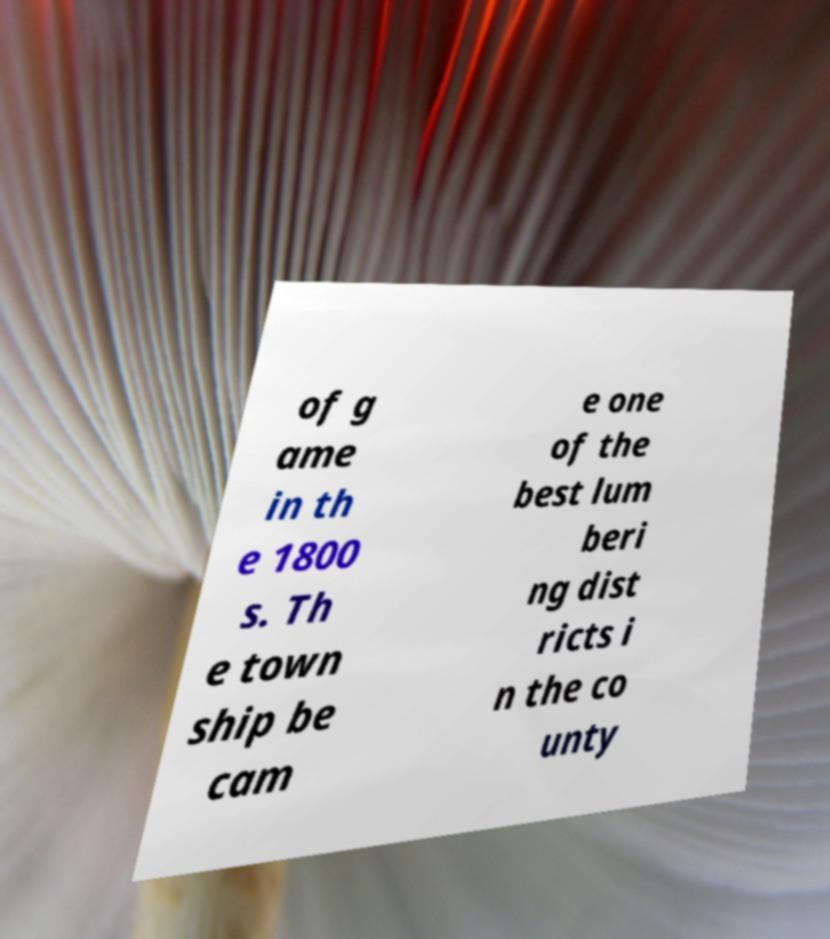For documentation purposes, I need the text within this image transcribed. Could you provide that? of g ame in th e 1800 s. Th e town ship be cam e one of the best lum beri ng dist ricts i n the co unty 